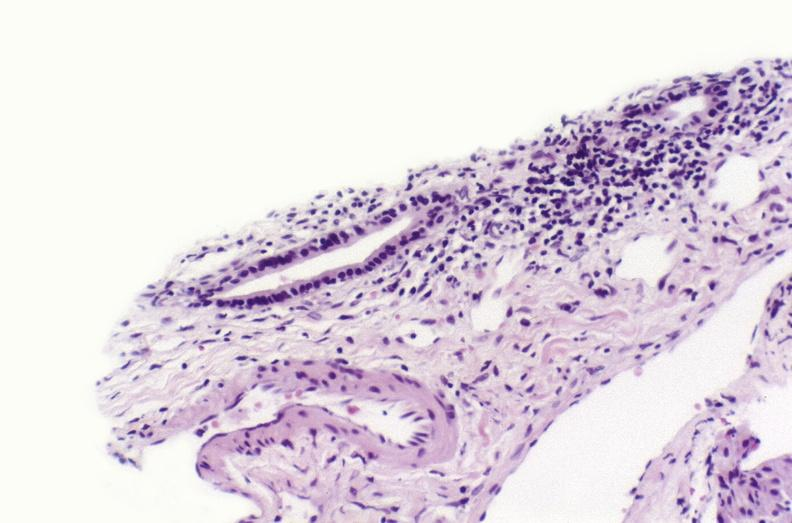does small intestine show sarcoid?
Answer the question using a single word or phrase. No 